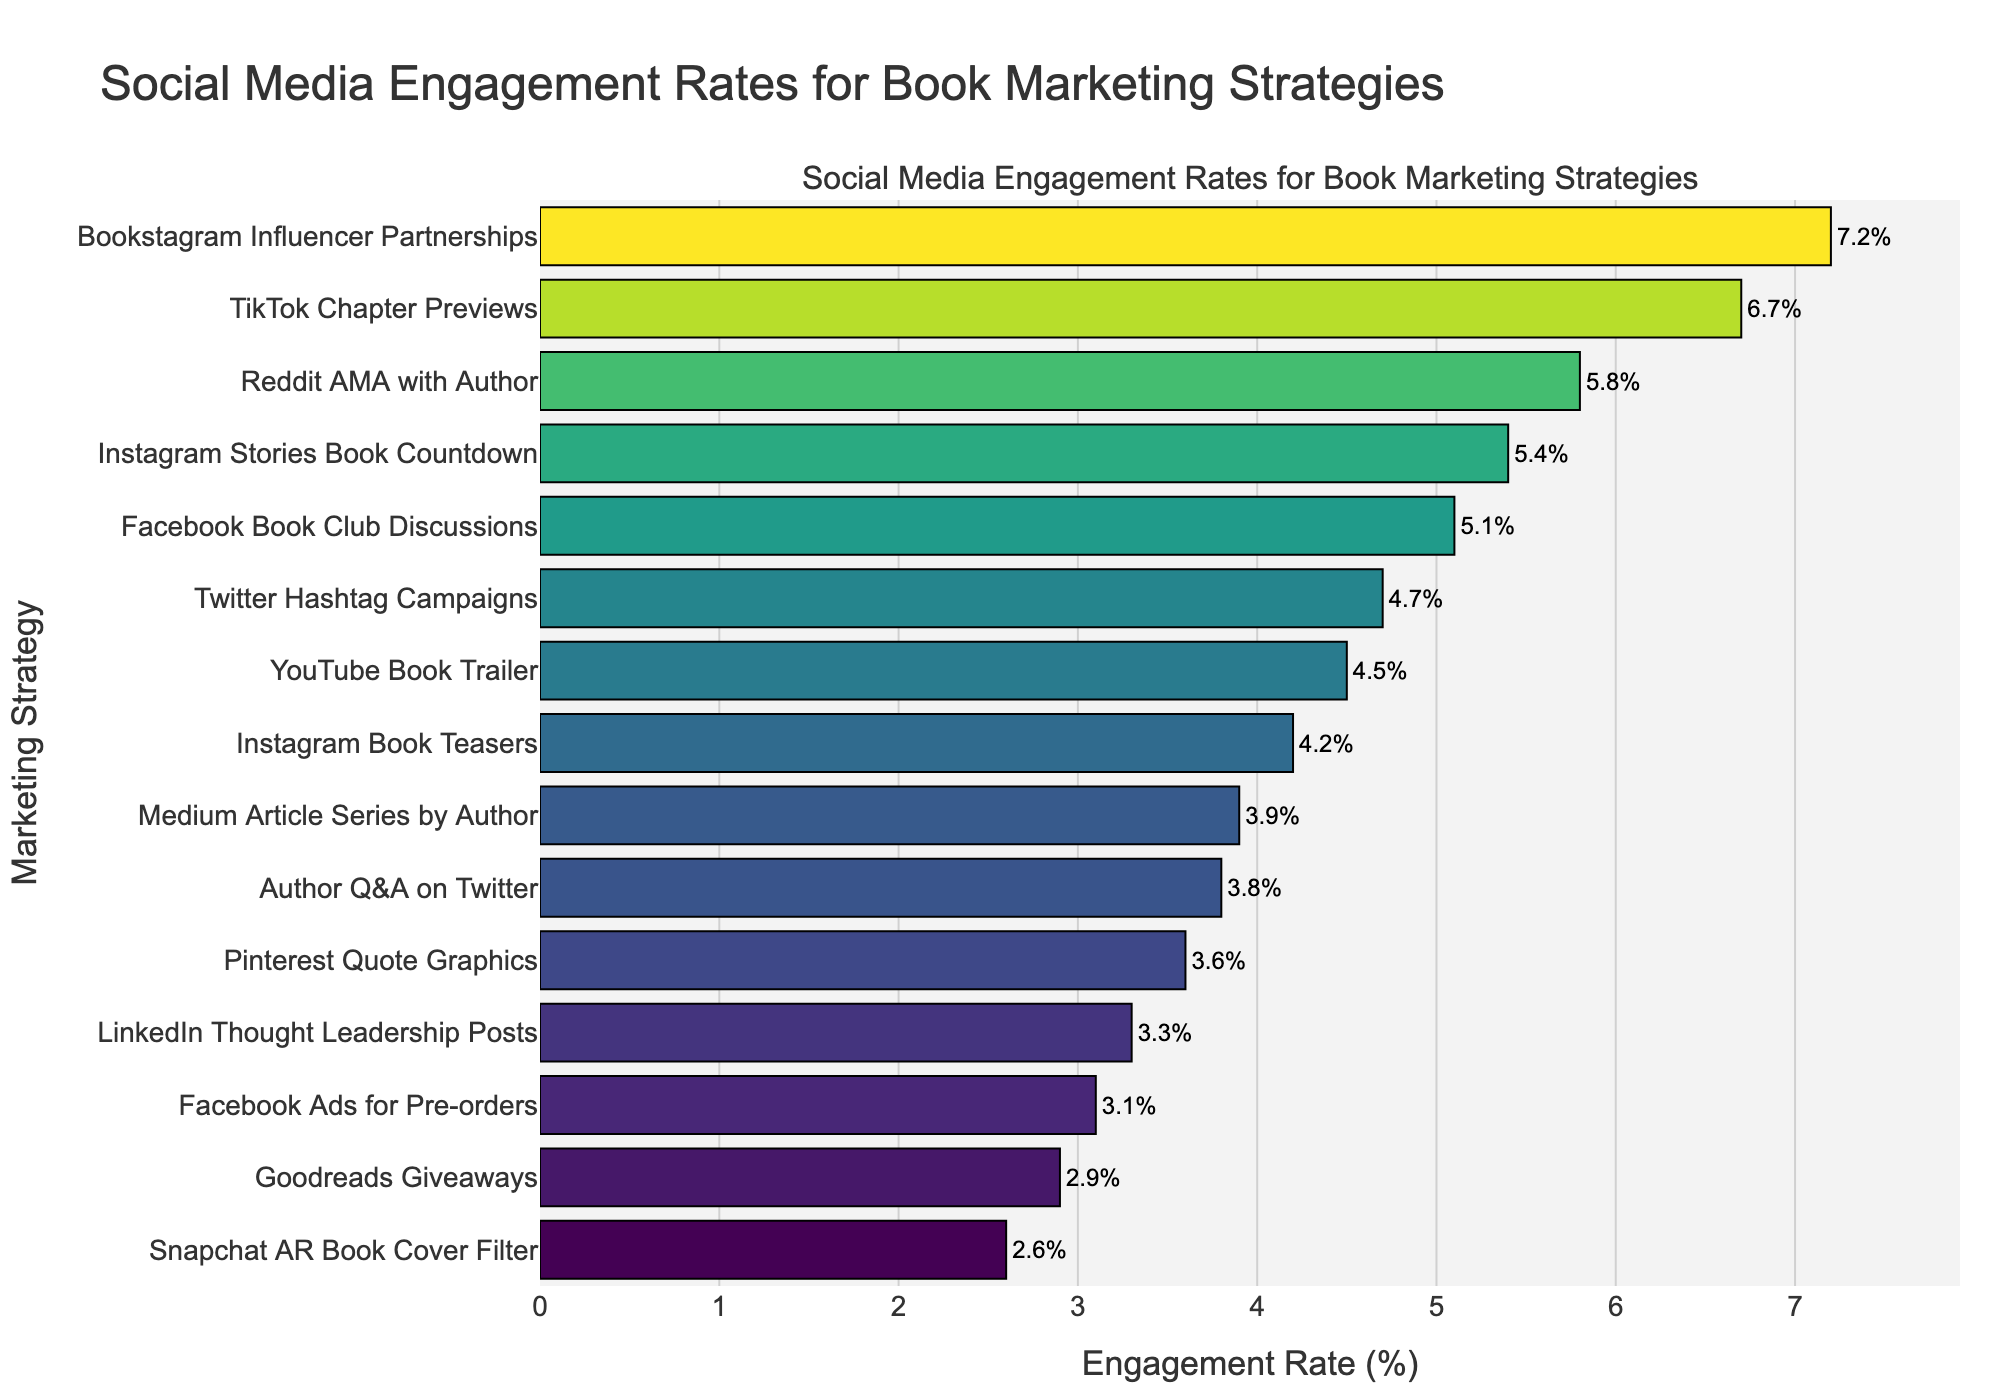Which marketing strategy has the highest engagement rate? First, identify the strategy with the longest bar. This represents "Bookstagram Influencer Partnerships" with an engagement rate of 7.2%.
Answer: Bookstagram Influencer Partnerships Which platform shows a higher engagement rate: Instagram Book Teasers or Facebook Book Club Discussions? Compare the engagement rates of the two strategies. Instagram Book Teasers has an engagement rate of 4.2%, while Facebook Book Club Discussions has 5.1%.
Answer: Facebook Book Club Discussions What is the combined engagement rate of all strategies involving Twitter? The two Twitter-related strategies are Author Q&A on Twitter (3.8%) and Twitter Hashtag Campaigns (4.7%). Add these rates together: 3.8% + 4.7% = 8.5%.
Answer: 8.5% Is the engagement rate for TikTok Chapter Previews greater than or equal to twice the rate for Goodreads Giveaways? The engagement rate for TikTok Chapter Previews is 6.7%. Twice the engagement rate for Goodreads Giveaways (2.9%) is 2.9% * 2 = 5.8%. Since 6.7% is greater than 5.8%, the answer is yes.
Answer: Yes Which strategy has the lowest engagement rate, and what is its value? Look for the shortest bar, which represents "Snapchat AR Book Cover Filter" with an engagement rate of 2.6%.
Answer: Snapchat AR Book Cover Filter, 2.6% How many strategies have an engagement rate higher than 5%? Identify strategies with engagement rates above 5%. They are TikTok Chapter Previews (6.7%), Facebook Book Club Discussions (5.1%), Instagram Stories Book Countdown (5.4%), Reddit AMA with Author (5.8%), and Bookstagram Influencer Partnerships (7.2%). There are 5 such strategies.
Answer: 5 What is the average engagement rate for the three highest-performing strategies? The top three strategies are Bookstagram Influencer Partnerships (7.2%), TikTok Chapter Previews (6.7%), and Reddit AMA with Author (5.8%). The average is calculated as (7.2 + 6.7 + 5.8) / 3 = 19.7 / 3 = 6.57.
Answer: 6.57 Compare the engagement rates of YouTube Book Trailer and LinkedIn Thought Leadership Posts. Which one is higher, and by how much? YouTube Book Trailer has an engagement rate of 4.5%, LinkedIn Thought Leadership Posts have 3.3%. The difference is 4.5% - 3.3% = 1.2%.
Answer: YouTube Book Trailer, 1.2% Which platforms have engagement rates between 3% and 4%? Identify platforms with engagement rates within this range. They are LinkedIn Thought Leadership Posts (3.3%), Pinterest Quote Graphics (3.6%), Medium Article Series by Author (3.9%), and Author Q&A on Twitter (3.8%).
Answer: LinkedIn, Pinterest, Medium, Twitter 